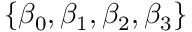<formula> <loc_0><loc_0><loc_500><loc_500>\{ \beta _ { 0 } , \beta _ { 1 } , \beta _ { 2 } , \beta _ { 3 } \}</formula> 